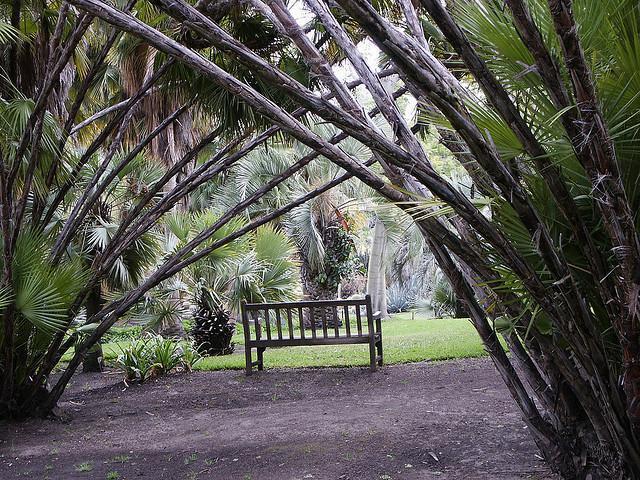How many beaches are near the grass?
Give a very brief answer. 1. How many benches can you see?
Give a very brief answer. 1. 